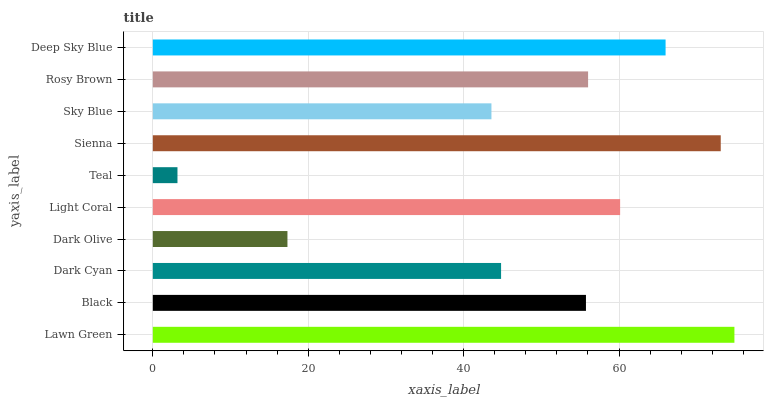Is Teal the minimum?
Answer yes or no. Yes. Is Lawn Green the maximum?
Answer yes or no. Yes. Is Black the minimum?
Answer yes or no. No. Is Black the maximum?
Answer yes or no. No. Is Lawn Green greater than Black?
Answer yes or no. Yes. Is Black less than Lawn Green?
Answer yes or no. Yes. Is Black greater than Lawn Green?
Answer yes or no. No. Is Lawn Green less than Black?
Answer yes or no. No. Is Rosy Brown the high median?
Answer yes or no. Yes. Is Black the low median?
Answer yes or no. Yes. Is Sky Blue the high median?
Answer yes or no. No. Is Dark Cyan the low median?
Answer yes or no. No. 